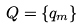<formula> <loc_0><loc_0><loc_500><loc_500>Q = \{ q _ { m } \}</formula> 